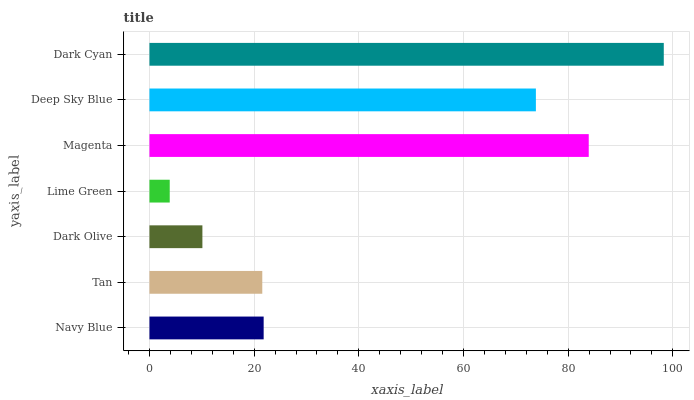Is Lime Green the minimum?
Answer yes or no. Yes. Is Dark Cyan the maximum?
Answer yes or no. Yes. Is Tan the minimum?
Answer yes or no. No. Is Tan the maximum?
Answer yes or no. No. Is Navy Blue greater than Tan?
Answer yes or no. Yes. Is Tan less than Navy Blue?
Answer yes or no. Yes. Is Tan greater than Navy Blue?
Answer yes or no. No. Is Navy Blue less than Tan?
Answer yes or no. No. Is Navy Blue the high median?
Answer yes or no. Yes. Is Navy Blue the low median?
Answer yes or no. Yes. Is Magenta the high median?
Answer yes or no. No. Is Lime Green the low median?
Answer yes or no. No. 